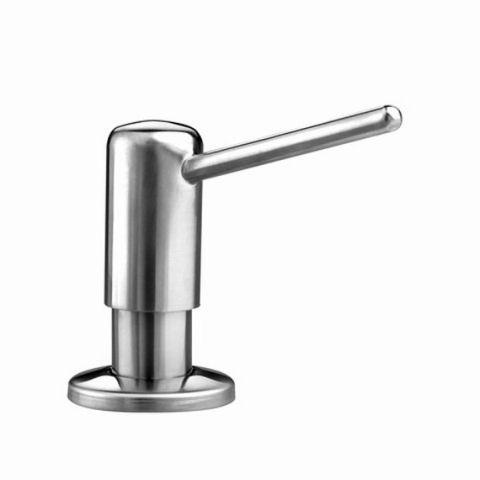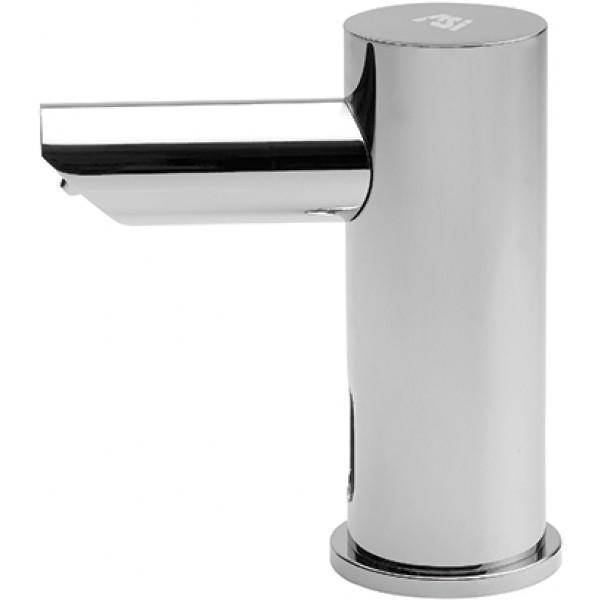The first image is the image on the left, the second image is the image on the right. Assess this claim about the two images: "The left and right image contains the same number of wall soap dispensers.". Correct or not? Answer yes or no. No. The first image is the image on the left, the second image is the image on the right. Given the left and right images, does the statement "Each image shows a bank of three lotion dispensers, but only one set has the contents written on each dispenser." hold true? Answer yes or no. No. 